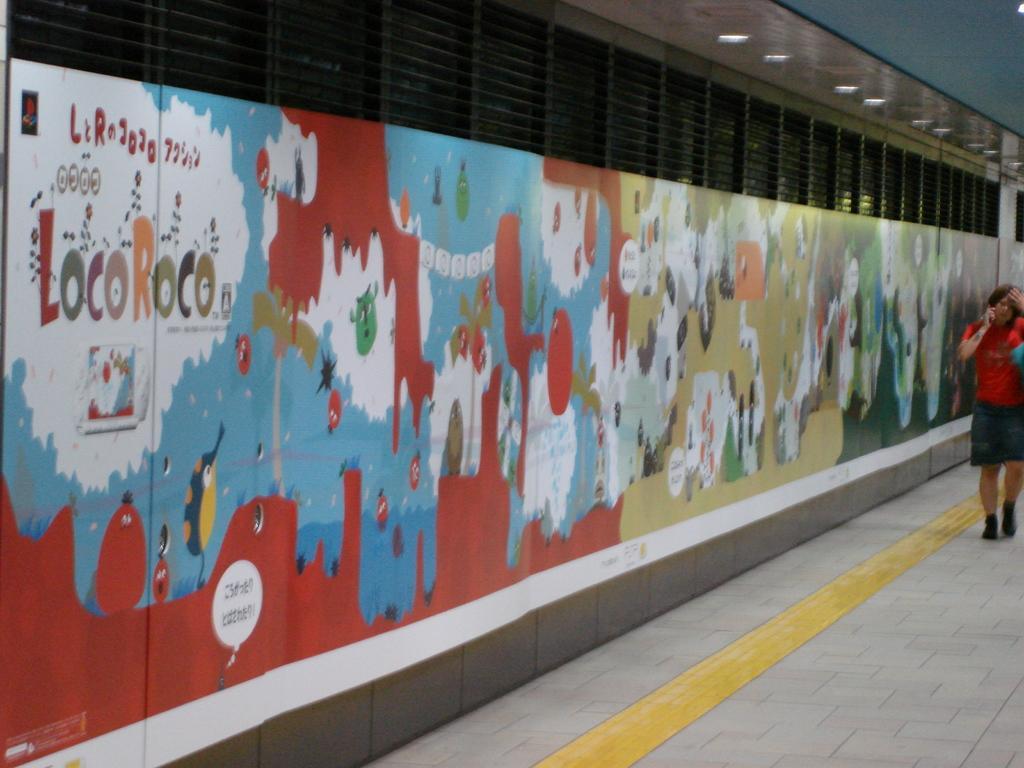Can you describe this image briefly? In this image, we can see a wall contains designs and some text. There is a person on the right side of the image wearing clothes. There are lights in the top right of the image. 